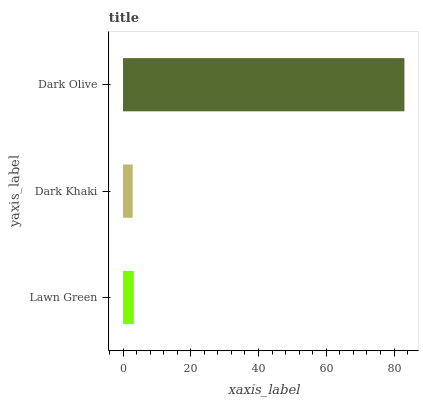Is Dark Khaki the minimum?
Answer yes or no. Yes. Is Dark Olive the maximum?
Answer yes or no. Yes. Is Dark Olive the minimum?
Answer yes or no. No. Is Dark Khaki the maximum?
Answer yes or no. No. Is Dark Olive greater than Dark Khaki?
Answer yes or no. Yes. Is Dark Khaki less than Dark Olive?
Answer yes or no. Yes. Is Dark Khaki greater than Dark Olive?
Answer yes or no. No. Is Dark Olive less than Dark Khaki?
Answer yes or no. No. Is Lawn Green the high median?
Answer yes or no. Yes. Is Lawn Green the low median?
Answer yes or no. Yes. Is Dark Khaki the high median?
Answer yes or no. No. Is Dark Olive the low median?
Answer yes or no. No. 